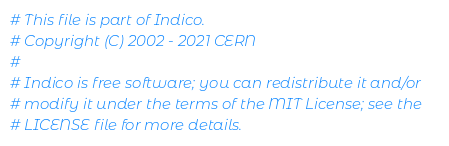Convert code to text. <code><loc_0><loc_0><loc_500><loc_500><_Python_># This file is part of Indico.
# Copyright (C) 2002 - 2021 CERN
#
# Indico is free software; you can redistribute it and/or
# modify it under the terms of the MIT License; see the
# LICENSE file for more details.
</code> 